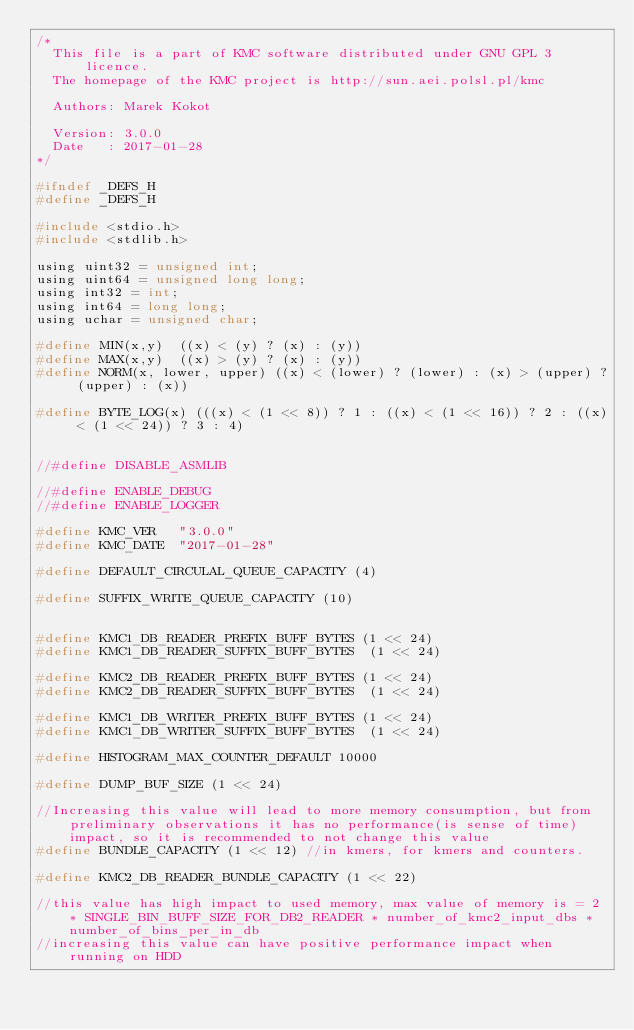<code> <loc_0><loc_0><loc_500><loc_500><_C_>/*
  This file is a part of KMC software distributed under GNU GPL 3 licence.
  The homepage of the KMC project is http://sun.aei.polsl.pl/kmc
  
  Authors: Marek Kokot
  
  Version: 3.0.0
  Date   : 2017-01-28
*/

#ifndef _DEFS_H
#define _DEFS_H

#include <stdio.h>
#include <stdlib.h>

using uint32 = unsigned int;
using uint64 = unsigned long long;
using int32 = int;
using int64 = long long;
using uchar = unsigned char;

#define MIN(x,y)	((x) < (y) ? (x) : (y))
#define MAX(x,y)	((x) > (y) ? (x) : (y))
#define NORM(x, lower, upper)	((x) < (lower) ? (lower) : (x) > (upper) ? (upper) : (x))

#define BYTE_LOG(x) (((x) < (1 << 8)) ? 1 : ((x) < (1 << 16)) ? 2 : ((x) < (1 << 24)) ? 3 : 4)


//#define DISABLE_ASMLIB

//#define ENABLE_DEBUG
//#define ENABLE_LOGGER

#define KMC_VER		"3.0.0"
#define KMC_DATE	"2017-01-28"

#define DEFAULT_CIRCULAL_QUEUE_CAPACITY (4)

#define SUFFIX_WRITE_QUEUE_CAPACITY (10)


#define KMC1_DB_READER_PREFIX_BUFF_BYTES (1 << 24)
#define KMC1_DB_READER_SUFFIX_BUFF_BYTES  (1 << 24)

#define KMC2_DB_READER_PREFIX_BUFF_BYTES (1 << 24)
#define KMC2_DB_READER_SUFFIX_BUFF_BYTES  (1 << 24)

#define KMC1_DB_WRITER_PREFIX_BUFF_BYTES (1 << 24)
#define KMC1_DB_WRITER_SUFFIX_BUFF_BYTES  (1 << 24)

#define HISTOGRAM_MAX_COUNTER_DEFAULT 10000

#define DUMP_BUF_SIZE (1 << 24)

//Increasing this value will lead to more memory consumption, but from preliminary observations it has no performance(is sense of time) impact, so it is recommended to not change this value
#define BUNDLE_CAPACITY (1 << 12) //in kmers, for kmers and counters. 

#define KMC2_DB_READER_BUNDLE_CAPACITY (1 << 22)

//this value has high impact to used memory, max value of memory is = 2 * SINGLE_BIN_BUFF_SIZE_FOR_DB2_READER * number_of_kmc2_input_dbs * number_of_bins_per_in_db
//increasing this value can have positive performance impact when running on HDD</code> 